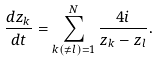<formula> <loc_0><loc_0><loc_500><loc_500>\frac { d { z } _ { k } } { d t } = \sum _ { k ( \neq l ) = 1 } ^ { N } \frac { 4 i } { { z } _ { k } - { z } _ { l } } .</formula> 